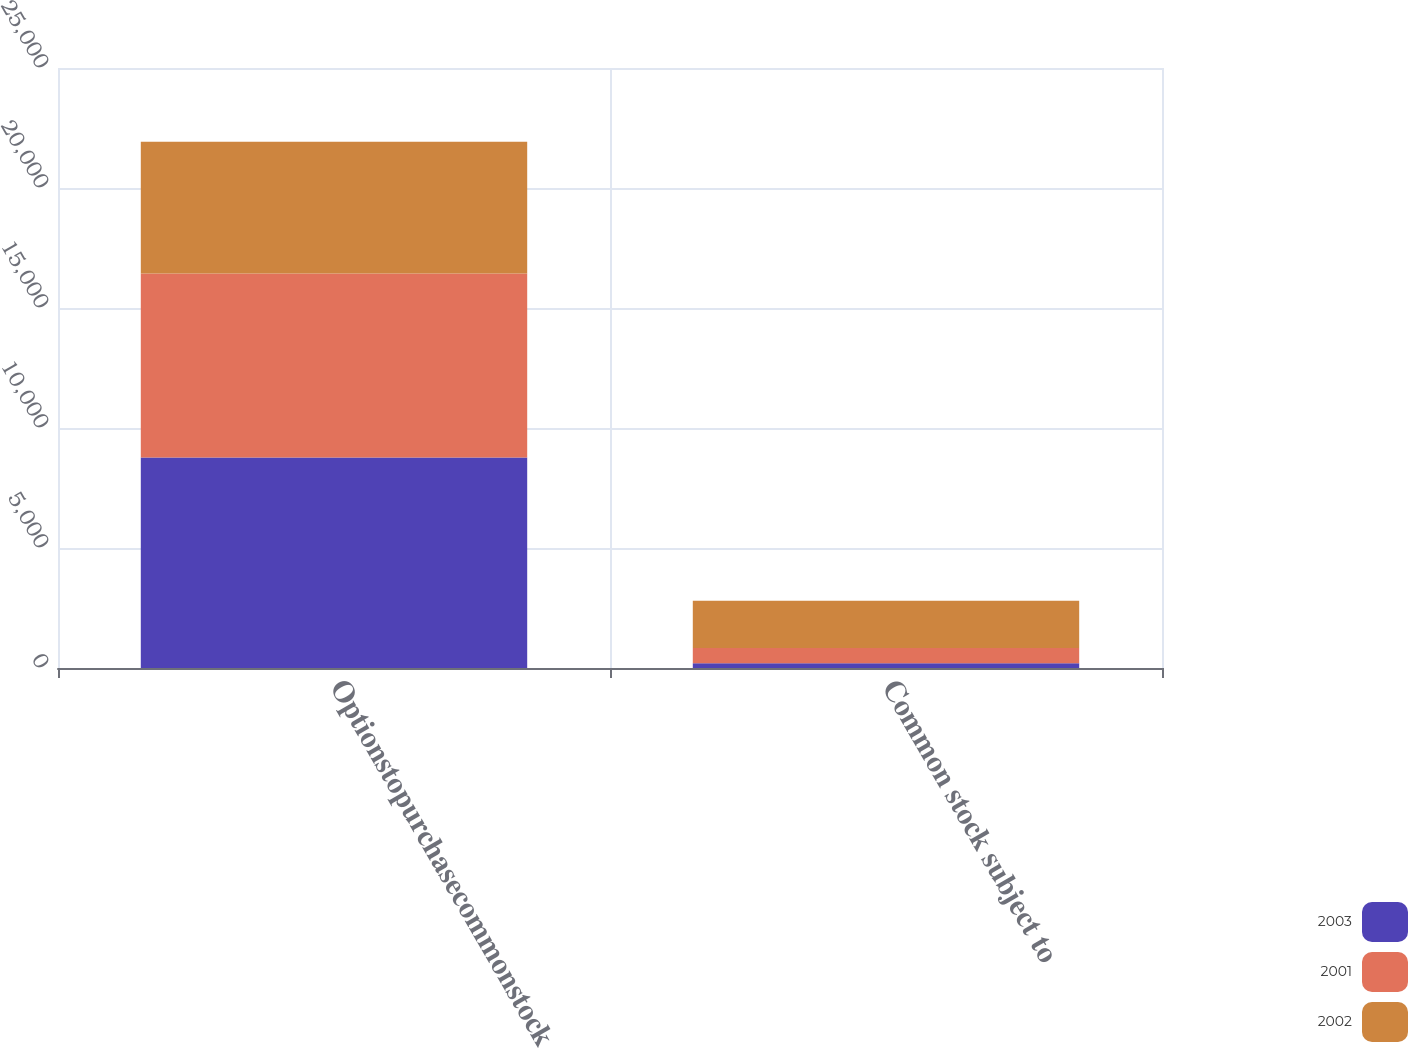Convert chart to OTSL. <chart><loc_0><loc_0><loc_500><loc_500><stacked_bar_chart><ecel><fcel>Optionstopurchasecommonstock<fcel>Common stock subject to<nl><fcel>2003<fcel>8767<fcel>200<nl><fcel>2001<fcel>7670<fcel>637<nl><fcel>2002<fcel>5489<fcel>1969<nl></chart> 